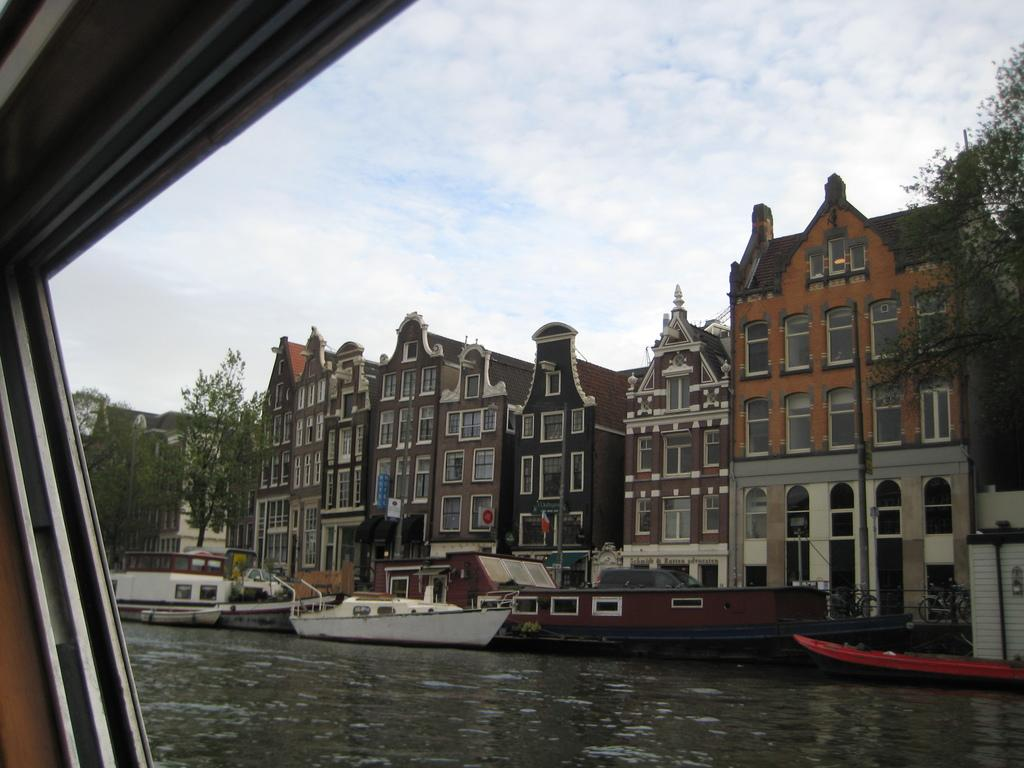What type of structures can be seen in the image? There are buildings in the image. What other natural elements are present in the image? There are trees in the image. What can be seen in the water in the image? There are boats in the water in the image. How would you describe the sky in the image? The sky is cloudy in the image. From where might the image have been taken? The image appears to be taken from a boat. What type of furniture is visible in the image? There is no furniture present in the image. What degree of difficulty is the boat facing in the image? The image does not provide any information about the boat's difficulty level or any other challenges it might be facing. 